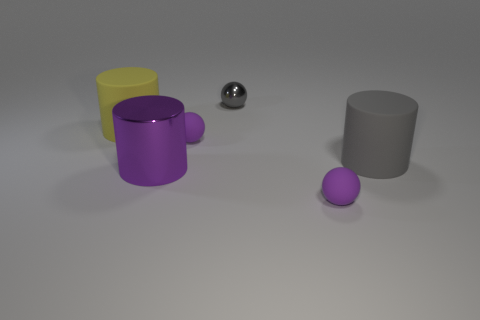Add 3 yellow rubber things. How many objects exist? 9 Subtract all small green cylinders. Subtract all large purple metallic objects. How many objects are left? 5 Add 5 purple cylinders. How many purple cylinders are left? 6 Add 5 large purple objects. How many large purple objects exist? 6 Subtract 0 cyan cylinders. How many objects are left? 6 